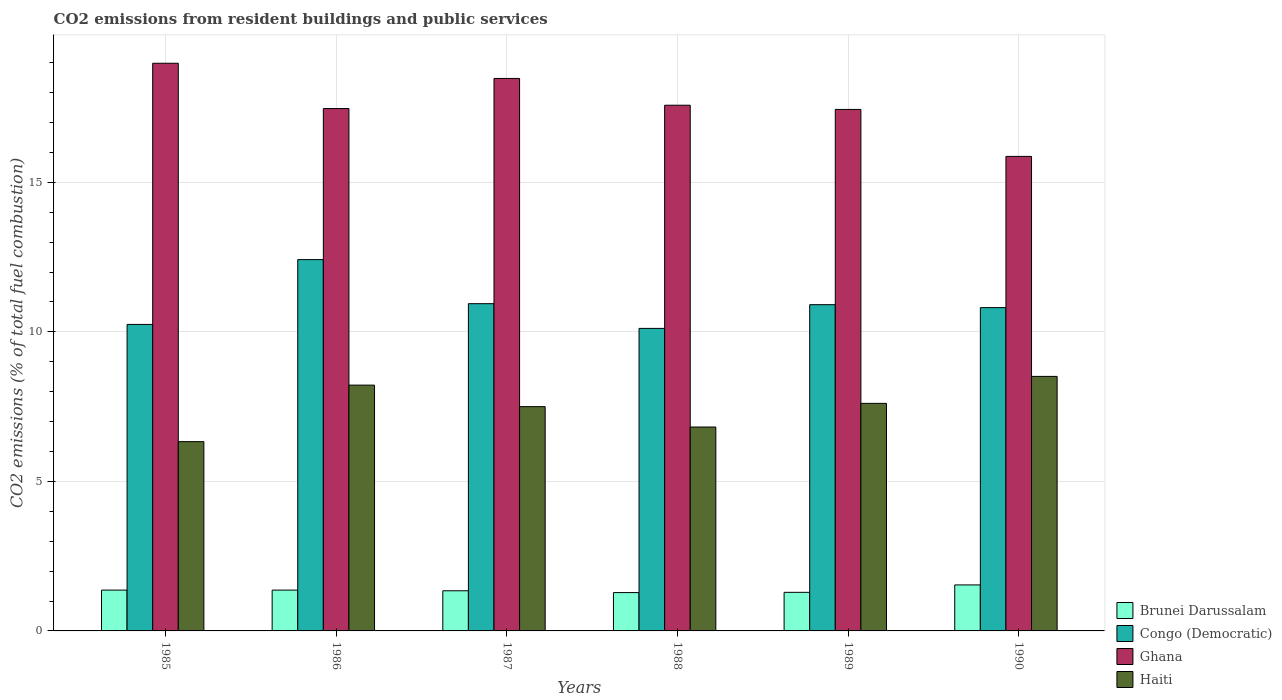Are the number of bars per tick equal to the number of legend labels?
Give a very brief answer. Yes. How many bars are there on the 2nd tick from the left?
Offer a very short reply. 4. What is the label of the 2nd group of bars from the left?
Make the answer very short. 1986. Across all years, what is the maximum total CO2 emitted in Brunei Darussalam?
Give a very brief answer. 1.54. Across all years, what is the minimum total CO2 emitted in Brunei Darussalam?
Your answer should be very brief. 1.28. In which year was the total CO2 emitted in Ghana minimum?
Provide a succinct answer. 1990. What is the total total CO2 emitted in Haiti in the graph?
Give a very brief answer. 44.99. What is the difference between the total CO2 emitted in Ghana in 1985 and that in 1990?
Provide a succinct answer. 3.11. What is the difference between the total CO2 emitted in Brunei Darussalam in 1988 and the total CO2 emitted in Haiti in 1989?
Offer a terse response. -6.33. What is the average total CO2 emitted in Ghana per year?
Offer a terse response. 17.63. In the year 1985, what is the difference between the total CO2 emitted in Congo (Democratic) and total CO2 emitted in Brunei Darussalam?
Ensure brevity in your answer.  8.88. What is the ratio of the total CO2 emitted in Haiti in 1986 to that in 1989?
Offer a very short reply. 1.08. Is the total CO2 emitted in Haiti in 1988 less than that in 1990?
Provide a short and direct response. Yes. Is the difference between the total CO2 emitted in Congo (Democratic) in 1988 and 1989 greater than the difference between the total CO2 emitted in Brunei Darussalam in 1988 and 1989?
Offer a terse response. No. What is the difference between the highest and the second highest total CO2 emitted in Brunei Darussalam?
Give a very brief answer. 0.17. What is the difference between the highest and the lowest total CO2 emitted in Congo (Democratic)?
Offer a terse response. 2.3. Is the sum of the total CO2 emitted in Congo (Democratic) in 1985 and 1989 greater than the maximum total CO2 emitted in Brunei Darussalam across all years?
Provide a short and direct response. Yes. What does the 4th bar from the left in 1989 represents?
Make the answer very short. Haiti. What does the 3rd bar from the right in 1985 represents?
Make the answer very short. Congo (Democratic). Is it the case that in every year, the sum of the total CO2 emitted in Congo (Democratic) and total CO2 emitted in Brunei Darussalam is greater than the total CO2 emitted in Ghana?
Give a very brief answer. No. Are all the bars in the graph horizontal?
Your answer should be compact. No. What is the difference between two consecutive major ticks on the Y-axis?
Your response must be concise. 5. How are the legend labels stacked?
Give a very brief answer. Vertical. What is the title of the graph?
Your answer should be very brief. CO2 emissions from resident buildings and public services. Does "Congo (Republic)" appear as one of the legend labels in the graph?
Keep it short and to the point. No. What is the label or title of the Y-axis?
Make the answer very short. CO2 emissions (% of total fuel combustion). What is the CO2 emissions (% of total fuel combustion) of Brunei Darussalam in 1985?
Your response must be concise. 1.37. What is the CO2 emissions (% of total fuel combustion) in Congo (Democratic) in 1985?
Provide a succinct answer. 10.25. What is the CO2 emissions (% of total fuel combustion) of Ghana in 1985?
Give a very brief answer. 18.98. What is the CO2 emissions (% of total fuel combustion) of Haiti in 1985?
Provide a succinct answer. 6.33. What is the CO2 emissions (% of total fuel combustion) of Brunei Darussalam in 1986?
Provide a succinct answer. 1.37. What is the CO2 emissions (% of total fuel combustion) of Congo (Democratic) in 1986?
Offer a terse response. 12.42. What is the CO2 emissions (% of total fuel combustion) in Ghana in 1986?
Provide a succinct answer. 17.47. What is the CO2 emissions (% of total fuel combustion) in Haiti in 1986?
Your answer should be compact. 8.22. What is the CO2 emissions (% of total fuel combustion) in Brunei Darussalam in 1987?
Make the answer very short. 1.34. What is the CO2 emissions (% of total fuel combustion) in Congo (Democratic) in 1987?
Keep it short and to the point. 10.94. What is the CO2 emissions (% of total fuel combustion) in Ghana in 1987?
Ensure brevity in your answer.  18.47. What is the CO2 emissions (% of total fuel combustion) in Haiti in 1987?
Ensure brevity in your answer.  7.5. What is the CO2 emissions (% of total fuel combustion) in Brunei Darussalam in 1988?
Offer a terse response. 1.28. What is the CO2 emissions (% of total fuel combustion) in Congo (Democratic) in 1988?
Provide a succinct answer. 10.12. What is the CO2 emissions (% of total fuel combustion) in Ghana in 1988?
Provide a short and direct response. 17.58. What is the CO2 emissions (% of total fuel combustion) of Haiti in 1988?
Offer a terse response. 6.82. What is the CO2 emissions (% of total fuel combustion) in Brunei Darussalam in 1989?
Provide a succinct answer. 1.29. What is the CO2 emissions (% of total fuel combustion) of Congo (Democratic) in 1989?
Keep it short and to the point. 10.91. What is the CO2 emissions (% of total fuel combustion) of Ghana in 1989?
Ensure brevity in your answer.  17.44. What is the CO2 emissions (% of total fuel combustion) in Haiti in 1989?
Your response must be concise. 7.61. What is the CO2 emissions (% of total fuel combustion) of Brunei Darussalam in 1990?
Your answer should be compact. 1.54. What is the CO2 emissions (% of total fuel combustion) in Congo (Democratic) in 1990?
Offer a very short reply. 10.81. What is the CO2 emissions (% of total fuel combustion) in Ghana in 1990?
Provide a succinct answer. 15.87. What is the CO2 emissions (% of total fuel combustion) of Haiti in 1990?
Make the answer very short. 8.51. Across all years, what is the maximum CO2 emissions (% of total fuel combustion) of Brunei Darussalam?
Offer a terse response. 1.54. Across all years, what is the maximum CO2 emissions (% of total fuel combustion) of Congo (Democratic)?
Offer a terse response. 12.42. Across all years, what is the maximum CO2 emissions (% of total fuel combustion) of Ghana?
Your response must be concise. 18.98. Across all years, what is the maximum CO2 emissions (% of total fuel combustion) of Haiti?
Offer a very short reply. 8.51. Across all years, what is the minimum CO2 emissions (% of total fuel combustion) of Brunei Darussalam?
Ensure brevity in your answer.  1.28. Across all years, what is the minimum CO2 emissions (% of total fuel combustion) in Congo (Democratic)?
Keep it short and to the point. 10.12. Across all years, what is the minimum CO2 emissions (% of total fuel combustion) in Ghana?
Offer a very short reply. 15.87. Across all years, what is the minimum CO2 emissions (% of total fuel combustion) in Haiti?
Your response must be concise. 6.33. What is the total CO2 emissions (% of total fuel combustion) of Brunei Darussalam in the graph?
Provide a succinct answer. 8.18. What is the total CO2 emissions (% of total fuel combustion) in Congo (Democratic) in the graph?
Provide a short and direct response. 65.44. What is the total CO2 emissions (% of total fuel combustion) of Ghana in the graph?
Offer a very short reply. 105.81. What is the total CO2 emissions (% of total fuel combustion) of Haiti in the graph?
Your response must be concise. 44.99. What is the difference between the CO2 emissions (% of total fuel combustion) of Brunei Darussalam in 1985 and that in 1986?
Provide a succinct answer. 0. What is the difference between the CO2 emissions (% of total fuel combustion) in Congo (Democratic) in 1985 and that in 1986?
Offer a very short reply. -2.17. What is the difference between the CO2 emissions (% of total fuel combustion) of Ghana in 1985 and that in 1986?
Ensure brevity in your answer.  1.51. What is the difference between the CO2 emissions (% of total fuel combustion) of Haiti in 1985 and that in 1986?
Your answer should be compact. -1.89. What is the difference between the CO2 emissions (% of total fuel combustion) in Brunei Darussalam in 1985 and that in 1987?
Your answer should be very brief. 0.02. What is the difference between the CO2 emissions (% of total fuel combustion) in Congo (Democratic) in 1985 and that in 1987?
Your answer should be compact. -0.69. What is the difference between the CO2 emissions (% of total fuel combustion) in Ghana in 1985 and that in 1987?
Keep it short and to the point. 0.51. What is the difference between the CO2 emissions (% of total fuel combustion) in Haiti in 1985 and that in 1987?
Offer a terse response. -1.17. What is the difference between the CO2 emissions (% of total fuel combustion) of Brunei Darussalam in 1985 and that in 1988?
Your response must be concise. 0.08. What is the difference between the CO2 emissions (% of total fuel combustion) in Congo (Democratic) in 1985 and that in 1988?
Your answer should be compact. 0.13. What is the difference between the CO2 emissions (% of total fuel combustion) of Ghana in 1985 and that in 1988?
Ensure brevity in your answer.  1.4. What is the difference between the CO2 emissions (% of total fuel combustion) in Haiti in 1985 and that in 1988?
Provide a succinct answer. -0.49. What is the difference between the CO2 emissions (% of total fuel combustion) in Brunei Darussalam in 1985 and that in 1989?
Your answer should be compact. 0.07. What is the difference between the CO2 emissions (% of total fuel combustion) of Congo (Democratic) in 1985 and that in 1989?
Your answer should be very brief. -0.66. What is the difference between the CO2 emissions (% of total fuel combustion) in Ghana in 1985 and that in 1989?
Your answer should be very brief. 1.54. What is the difference between the CO2 emissions (% of total fuel combustion) of Haiti in 1985 and that in 1989?
Provide a short and direct response. -1.28. What is the difference between the CO2 emissions (% of total fuel combustion) of Brunei Darussalam in 1985 and that in 1990?
Offer a terse response. -0.17. What is the difference between the CO2 emissions (% of total fuel combustion) of Congo (Democratic) in 1985 and that in 1990?
Offer a terse response. -0.56. What is the difference between the CO2 emissions (% of total fuel combustion) of Ghana in 1985 and that in 1990?
Provide a short and direct response. 3.11. What is the difference between the CO2 emissions (% of total fuel combustion) in Haiti in 1985 and that in 1990?
Provide a succinct answer. -2.18. What is the difference between the CO2 emissions (% of total fuel combustion) of Brunei Darussalam in 1986 and that in 1987?
Provide a succinct answer. 0.02. What is the difference between the CO2 emissions (% of total fuel combustion) in Congo (Democratic) in 1986 and that in 1987?
Provide a succinct answer. 1.47. What is the difference between the CO2 emissions (% of total fuel combustion) in Ghana in 1986 and that in 1987?
Provide a short and direct response. -1.01. What is the difference between the CO2 emissions (% of total fuel combustion) in Haiti in 1986 and that in 1987?
Give a very brief answer. 0.72. What is the difference between the CO2 emissions (% of total fuel combustion) in Brunei Darussalam in 1986 and that in 1988?
Give a very brief answer. 0.08. What is the difference between the CO2 emissions (% of total fuel combustion) of Congo (Democratic) in 1986 and that in 1988?
Offer a very short reply. 2.3. What is the difference between the CO2 emissions (% of total fuel combustion) in Ghana in 1986 and that in 1988?
Offer a terse response. -0.11. What is the difference between the CO2 emissions (% of total fuel combustion) of Haiti in 1986 and that in 1988?
Your answer should be very brief. 1.4. What is the difference between the CO2 emissions (% of total fuel combustion) of Brunei Darussalam in 1986 and that in 1989?
Offer a terse response. 0.07. What is the difference between the CO2 emissions (% of total fuel combustion) of Congo (Democratic) in 1986 and that in 1989?
Offer a terse response. 1.51. What is the difference between the CO2 emissions (% of total fuel combustion) in Ghana in 1986 and that in 1989?
Your response must be concise. 0.03. What is the difference between the CO2 emissions (% of total fuel combustion) of Haiti in 1986 and that in 1989?
Keep it short and to the point. 0.61. What is the difference between the CO2 emissions (% of total fuel combustion) of Brunei Darussalam in 1986 and that in 1990?
Your answer should be compact. -0.17. What is the difference between the CO2 emissions (% of total fuel combustion) of Congo (Democratic) in 1986 and that in 1990?
Provide a short and direct response. 1.61. What is the difference between the CO2 emissions (% of total fuel combustion) in Ghana in 1986 and that in 1990?
Make the answer very short. 1.6. What is the difference between the CO2 emissions (% of total fuel combustion) of Haiti in 1986 and that in 1990?
Provide a short and direct response. -0.29. What is the difference between the CO2 emissions (% of total fuel combustion) in Brunei Darussalam in 1987 and that in 1988?
Ensure brevity in your answer.  0.06. What is the difference between the CO2 emissions (% of total fuel combustion) of Congo (Democratic) in 1987 and that in 1988?
Ensure brevity in your answer.  0.83. What is the difference between the CO2 emissions (% of total fuel combustion) in Ghana in 1987 and that in 1988?
Provide a short and direct response. 0.9. What is the difference between the CO2 emissions (% of total fuel combustion) in Haiti in 1987 and that in 1988?
Give a very brief answer. 0.68. What is the difference between the CO2 emissions (% of total fuel combustion) in Brunei Darussalam in 1987 and that in 1989?
Ensure brevity in your answer.  0.05. What is the difference between the CO2 emissions (% of total fuel combustion) in Congo (Democratic) in 1987 and that in 1989?
Your answer should be very brief. 0.03. What is the difference between the CO2 emissions (% of total fuel combustion) of Ghana in 1987 and that in 1989?
Your response must be concise. 1.04. What is the difference between the CO2 emissions (% of total fuel combustion) of Haiti in 1987 and that in 1989?
Your answer should be compact. -0.11. What is the difference between the CO2 emissions (% of total fuel combustion) in Brunei Darussalam in 1987 and that in 1990?
Offer a very short reply. -0.2. What is the difference between the CO2 emissions (% of total fuel combustion) in Congo (Democratic) in 1987 and that in 1990?
Provide a short and direct response. 0.13. What is the difference between the CO2 emissions (% of total fuel combustion) in Ghana in 1987 and that in 1990?
Your answer should be very brief. 2.61. What is the difference between the CO2 emissions (% of total fuel combustion) in Haiti in 1987 and that in 1990?
Your answer should be very brief. -1.01. What is the difference between the CO2 emissions (% of total fuel combustion) in Brunei Darussalam in 1988 and that in 1989?
Make the answer very short. -0.01. What is the difference between the CO2 emissions (% of total fuel combustion) in Congo (Democratic) in 1988 and that in 1989?
Offer a very short reply. -0.79. What is the difference between the CO2 emissions (% of total fuel combustion) in Ghana in 1988 and that in 1989?
Your answer should be compact. 0.14. What is the difference between the CO2 emissions (% of total fuel combustion) in Haiti in 1988 and that in 1989?
Your answer should be compact. -0.79. What is the difference between the CO2 emissions (% of total fuel combustion) in Brunei Darussalam in 1988 and that in 1990?
Provide a succinct answer. -0.26. What is the difference between the CO2 emissions (% of total fuel combustion) of Congo (Democratic) in 1988 and that in 1990?
Your answer should be very brief. -0.7. What is the difference between the CO2 emissions (% of total fuel combustion) in Ghana in 1988 and that in 1990?
Your answer should be compact. 1.71. What is the difference between the CO2 emissions (% of total fuel combustion) of Haiti in 1988 and that in 1990?
Offer a very short reply. -1.69. What is the difference between the CO2 emissions (% of total fuel combustion) of Brunei Darussalam in 1989 and that in 1990?
Make the answer very short. -0.25. What is the difference between the CO2 emissions (% of total fuel combustion) in Congo (Democratic) in 1989 and that in 1990?
Offer a terse response. 0.1. What is the difference between the CO2 emissions (% of total fuel combustion) in Ghana in 1989 and that in 1990?
Provide a short and direct response. 1.57. What is the difference between the CO2 emissions (% of total fuel combustion) of Haiti in 1989 and that in 1990?
Your answer should be very brief. -0.9. What is the difference between the CO2 emissions (% of total fuel combustion) in Brunei Darussalam in 1985 and the CO2 emissions (% of total fuel combustion) in Congo (Democratic) in 1986?
Make the answer very short. -11.05. What is the difference between the CO2 emissions (% of total fuel combustion) in Brunei Darussalam in 1985 and the CO2 emissions (% of total fuel combustion) in Ghana in 1986?
Your answer should be compact. -16.1. What is the difference between the CO2 emissions (% of total fuel combustion) in Brunei Darussalam in 1985 and the CO2 emissions (% of total fuel combustion) in Haiti in 1986?
Offer a very short reply. -6.85. What is the difference between the CO2 emissions (% of total fuel combustion) in Congo (Democratic) in 1985 and the CO2 emissions (% of total fuel combustion) in Ghana in 1986?
Give a very brief answer. -7.22. What is the difference between the CO2 emissions (% of total fuel combustion) in Congo (Democratic) in 1985 and the CO2 emissions (% of total fuel combustion) in Haiti in 1986?
Keep it short and to the point. 2.03. What is the difference between the CO2 emissions (% of total fuel combustion) of Ghana in 1985 and the CO2 emissions (% of total fuel combustion) of Haiti in 1986?
Ensure brevity in your answer.  10.76. What is the difference between the CO2 emissions (% of total fuel combustion) in Brunei Darussalam in 1985 and the CO2 emissions (% of total fuel combustion) in Congo (Democratic) in 1987?
Your answer should be very brief. -9.58. What is the difference between the CO2 emissions (% of total fuel combustion) in Brunei Darussalam in 1985 and the CO2 emissions (% of total fuel combustion) in Ghana in 1987?
Provide a succinct answer. -17.11. What is the difference between the CO2 emissions (% of total fuel combustion) of Brunei Darussalam in 1985 and the CO2 emissions (% of total fuel combustion) of Haiti in 1987?
Make the answer very short. -6.13. What is the difference between the CO2 emissions (% of total fuel combustion) in Congo (Democratic) in 1985 and the CO2 emissions (% of total fuel combustion) in Ghana in 1987?
Provide a short and direct response. -8.23. What is the difference between the CO2 emissions (% of total fuel combustion) of Congo (Democratic) in 1985 and the CO2 emissions (% of total fuel combustion) of Haiti in 1987?
Provide a short and direct response. 2.75. What is the difference between the CO2 emissions (% of total fuel combustion) of Ghana in 1985 and the CO2 emissions (% of total fuel combustion) of Haiti in 1987?
Provide a short and direct response. 11.48. What is the difference between the CO2 emissions (% of total fuel combustion) in Brunei Darussalam in 1985 and the CO2 emissions (% of total fuel combustion) in Congo (Democratic) in 1988?
Offer a very short reply. -8.75. What is the difference between the CO2 emissions (% of total fuel combustion) of Brunei Darussalam in 1985 and the CO2 emissions (% of total fuel combustion) of Ghana in 1988?
Offer a very short reply. -16.21. What is the difference between the CO2 emissions (% of total fuel combustion) of Brunei Darussalam in 1985 and the CO2 emissions (% of total fuel combustion) of Haiti in 1988?
Offer a terse response. -5.45. What is the difference between the CO2 emissions (% of total fuel combustion) in Congo (Democratic) in 1985 and the CO2 emissions (% of total fuel combustion) in Ghana in 1988?
Give a very brief answer. -7.33. What is the difference between the CO2 emissions (% of total fuel combustion) of Congo (Democratic) in 1985 and the CO2 emissions (% of total fuel combustion) of Haiti in 1988?
Provide a short and direct response. 3.43. What is the difference between the CO2 emissions (% of total fuel combustion) in Ghana in 1985 and the CO2 emissions (% of total fuel combustion) in Haiti in 1988?
Make the answer very short. 12.16. What is the difference between the CO2 emissions (% of total fuel combustion) in Brunei Darussalam in 1985 and the CO2 emissions (% of total fuel combustion) in Congo (Democratic) in 1989?
Keep it short and to the point. -9.54. What is the difference between the CO2 emissions (% of total fuel combustion) in Brunei Darussalam in 1985 and the CO2 emissions (% of total fuel combustion) in Ghana in 1989?
Offer a terse response. -16.07. What is the difference between the CO2 emissions (% of total fuel combustion) in Brunei Darussalam in 1985 and the CO2 emissions (% of total fuel combustion) in Haiti in 1989?
Provide a succinct answer. -6.24. What is the difference between the CO2 emissions (% of total fuel combustion) in Congo (Democratic) in 1985 and the CO2 emissions (% of total fuel combustion) in Ghana in 1989?
Ensure brevity in your answer.  -7.19. What is the difference between the CO2 emissions (% of total fuel combustion) of Congo (Democratic) in 1985 and the CO2 emissions (% of total fuel combustion) of Haiti in 1989?
Ensure brevity in your answer.  2.64. What is the difference between the CO2 emissions (% of total fuel combustion) in Ghana in 1985 and the CO2 emissions (% of total fuel combustion) in Haiti in 1989?
Provide a short and direct response. 11.37. What is the difference between the CO2 emissions (% of total fuel combustion) in Brunei Darussalam in 1985 and the CO2 emissions (% of total fuel combustion) in Congo (Democratic) in 1990?
Offer a very short reply. -9.45. What is the difference between the CO2 emissions (% of total fuel combustion) of Brunei Darussalam in 1985 and the CO2 emissions (% of total fuel combustion) of Ghana in 1990?
Ensure brevity in your answer.  -14.5. What is the difference between the CO2 emissions (% of total fuel combustion) in Brunei Darussalam in 1985 and the CO2 emissions (% of total fuel combustion) in Haiti in 1990?
Provide a short and direct response. -7.15. What is the difference between the CO2 emissions (% of total fuel combustion) of Congo (Democratic) in 1985 and the CO2 emissions (% of total fuel combustion) of Ghana in 1990?
Make the answer very short. -5.62. What is the difference between the CO2 emissions (% of total fuel combustion) of Congo (Democratic) in 1985 and the CO2 emissions (% of total fuel combustion) of Haiti in 1990?
Make the answer very short. 1.74. What is the difference between the CO2 emissions (% of total fuel combustion) of Ghana in 1985 and the CO2 emissions (% of total fuel combustion) of Haiti in 1990?
Make the answer very short. 10.47. What is the difference between the CO2 emissions (% of total fuel combustion) of Brunei Darussalam in 1986 and the CO2 emissions (% of total fuel combustion) of Congo (Democratic) in 1987?
Your answer should be compact. -9.58. What is the difference between the CO2 emissions (% of total fuel combustion) of Brunei Darussalam in 1986 and the CO2 emissions (% of total fuel combustion) of Ghana in 1987?
Offer a terse response. -17.11. What is the difference between the CO2 emissions (% of total fuel combustion) in Brunei Darussalam in 1986 and the CO2 emissions (% of total fuel combustion) in Haiti in 1987?
Provide a short and direct response. -6.13. What is the difference between the CO2 emissions (% of total fuel combustion) in Congo (Democratic) in 1986 and the CO2 emissions (% of total fuel combustion) in Ghana in 1987?
Make the answer very short. -6.06. What is the difference between the CO2 emissions (% of total fuel combustion) of Congo (Democratic) in 1986 and the CO2 emissions (% of total fuel combustion) of Haiti in 1987?
Your answer should be compact. 4.92. What is the difference between the CO2 emissions (% of total fuel combustion) of Ghana in 1986 and the CO2 emissions (% of total fuel combustion) of Haiti in 1987?
Offer a terse response. 9.97. What is the difference between the CO2 emissions (% of total fuel combustion) of Brunei Darussalam in 1986 and the CO2 emissions (% of total fuel combustion) of Congo (Democratic) in 1988?
Ensure brevity in your answer.  -8.75. What is the difference between the CO2 emissions (% of total fuel combustion) of Brunei Darussalam in 1986 and the CO2 emissions (% of total fuel combustion) of Ghana in 1988?
Provide a short and direct response. -16.21. What is the difference between the CO2 emissions (% of total fuel combustion) in Brunei Darussalam in 1986 and the CO2 emissions (% of total fuel combustion) in Haiti in 1988?
Your answer should be compact. -5.45. What is the difference between the CO2 emissions (% of total fuel combustion) in Congo (Democratic) in 1986 and the CO2 emissions (% of total fuel combustion) in Ghana in 1988?
Provide a succinct answer. -5.16. What is the difference between the CO2 emissions (% of total fuel combustion) in Congo (Democratic) in 1986 and the CO2 emissions (% of total fuel combustion) in Haiti in 1988?
Ensure brevity in your answer.  5.6. What is the difference between the CO2 emissions (% of total fuel combustion) in Ghana in 1986 and the CO2 emissions (% of total fuel combustion) in Haiti in 1988?
Your response must be concise. 10.65. What is the difference between the CO2 emissions (% of total fuel combustion) of Brunei Darussalam in 1986 and the CO2 emissions (% of total fuel combustion) of Congo (Democratic) in 1989?
Your answer should be very brief. -9.54. What is the difference between the CO2 emissions (% of total fuel combustion) in Brunei Darussalam in 1986 and the CO2 emissions (% of total fuel combustion) in Ghana in 1989?
Give a very brief answer. -16.07. What is the difference between the CO2 emissions (% of total fuel combustion) of Brunei Darussalam in 1986 and the CO2 emissions (% of total fuel combustion) of Haiti in 1989?
Your answer should be very brief. -6.24. What is the difference between the CO2 emissions (% of total fuel combustion) in Congo (Democratic) in 1986 and the CO2 emissions (% of total fuel combustion) in Ghana in 1989?
Offer a very short reply. -5.02. What is the difference between the CO2 emissions (% of total fuel combustion) of Congo (Democratic) in 1986 and the CO2 emissions (% of total fuel combustion) of Haiti in 1989?
Ensure brevity in your answer.  4.81. What is the difference between the CO2 emissions (% of total fuel combustion) in Ghana in 1986 and the CO2 emissions (% of total fuel combustion) in Haiti in 1989?
Your answer should be compact. 9.86. What is the difference between the CO2 emissions (% of total fuel combustion) of Brunei Darussalam in 1986 and the CO2 emissions (% of total fuel combustion) of Congo (Democratic) in 1990?
Ensure brevity in your answer.  -9.45. What is the difference between the CO2 emissions (% of total fuel combustion) of Brunei Darussalam in 1986 and the CO2 emissions (% of total fuel combustion) of Ghana in 1990?
Offer a very short reply. -14.5. What is the difference between the CO2 emissions (% of total fuel combustion) in Brunei Darussalam in 1986 and the CO2 emissions (% of total fuel combustion) in Haiti in 1990?
Make the answer very short. -7.15. What is the difference between the CO2 emissions (% of total fuel combustion) in Congo (Democratic) in 1986 and the CO2 emissions (% of total fuel combustion) in Ghana in 1990?
Provide a succinct answer. -3.45. What is the difference between the CO2 emissions (% of total fuel combustion) of Congo (Democratic) in 1986 and the CO2 emissions (% of total fuel combustion) of Haiti in 1990?
Your answer should be compact. 3.91. What is the difference between the CO2 emissions (% of total fuel combustion) of Ghana in 1986 and the CO2 emissions (% of total fuel combustion) of Haiti in 1990?
Give a very brief answer. 8.96. What is the difference between the CO2 emissions (% of total fuel combustion) of Brunei Darussalam in 1987 and the CO2 emissions (% of total fuel combustion) of Congo (Democratic) in 1988?
Ensure brevity in your answer.  -8.77. What is the difference between the CO2 emissions (% of total fuel combustion) in Brunei Darussalam in 1987 and the CO2 emissions (% of total fuel combustion) in Ghana in 1988?
Offer a very short reply. -16.24. What is the difference between the CO2 emissions (% of total fuel combustion) in Brunei Darussalam in 1987 and the CO2 emissions (% of total fuel combustion) in Haiti in 1988?
Your answer should be very brief. -5.48. What is the difference between the CO2 emissions (% of total fuel combustion) in Congo (Democratic) in 1987 and the CO2 emissions (% of total fuel combustion) in Ghana in 1988?
Give a very brief answer. -6.64. What is the difference between the CO2 emissions (% of total fuel combustion) of Congo (Democratic) in 1987 and the CO2 emissions (% of total fuel combustion) of Haiti in 1988?
Offer a terse response. 4.12. What is the difference between the CO2 emissions (% of total fuel combustion) of Ghana in 1987 and the CO2 emissions (% of total fuel combustion) of Haiti in 1988?
Your response must be concise. 11.66. What is the difference between the CO2 emissions (% of total fuel combustion) of Brunei Darussalam in 1987 and the CO2 emissions (% of total fuel combustion) of Congo (Democratic) in 1989?
Keep it short and to the point. -9.57. What is the difference between the CO2 emissions (% of total fuel combustion) of Brunei Darussalam in 1987 and the CO2 emissions (% of total fuel combustion) of Ghana in 1989?
Make the answer very short. -16.1. What is the difference between the CO2 emissions (% of total fuel combustion) in Brunei Darussalam in 1987 and the CO2 emissions (% of total fuel combustion) in Haiti in 1989?
Provide a short and direct response. -6.27. What is the difference between the CO2 emissions (% of total fuel combustion) of Congo (Democratic) in 1987 and the CO2 emissions (% of total fuel combustion) of Ghana in 1989?
Your answer should be very brief. -6.5. What is the difference between the CO2 emissions (% of total fuel combustion) of Congo (Democratic) in 1987 and the CO2 emissions (% of total fuel combustion) of Haiti in 1989?
Offer a terse response. 3.33. What is the difference between the CO2 emissions (% of total fuel combustion) of Ghana in 1987 and the CO2 emissions (% of total fuel combustion) of Haiti in 1989?
Your response must be concise. 10.87. What is the difference between the CO2 emissions (% of total fuel combustion) in Brunei Darussalam in 1987 and the CO2 emissions (% of total fuel combustion) in Congo (Democratic) in 1990?
Your answer should be very brief. -9.47. What is the difference between the CO2 emissions (% of total fuel combustion) of Brunei Darussalam in 1987 and the CO2 emissions (% of total fuel combustion) of Ghana in 1990?
Offer a very short reply. -14.52. What is the difference between the CO2 emissions (% of total fuel combustion) in Brunei Darussalam in 1987 and the CO2 emissions (% of total fuel combustion) in Haiti in 1990?
Your answer should be very brief. -7.17. What is the difference between the CO2 emissions (% of total fuel combustion) of Congo (Democratic) in 1987 and the CO2 emissions (% of total fuel combustion) of Ghana in 1990?
Offer a terse response. -4.92. What is the difference between the CO2 emissions (% of total fuel combustion) in Congo (Democratic) in 1987 and the CO2 emissions (% of total fuel combustion) in Haiti in 1990?
Offer a terse response. 2.43. What is the difference between the CO2 emissions (% of total fuel combustion) of Ghana in 1987 and the CO2 emissions (% of total fuel combustion) of Haiti in 1990?
Your response must be concise. 9.96. What is the difference between the CO2 emissions (% of total fuel combustion) of Brunei Darussalam in 1988 and the CO2 emissions (% of total fuel combustion) of Congo (Democratic) in 1989?
Offer a very short reply. -9.63. What is the difference between the CO2 emissions (% of total fuel combustion) in Brunei Darussalam in 1988 and the CO2 emissions (% of total fuel combustion) in Ghana in 1989?
Offer a very short reply. -16.16. What is the difference between the CO2 emissions (% of total fuel combustion) of Brunei Darussalam in 1988 and the CO2 emissions (% of total fuel combustion) of Haiti in 1989?
Provide a short and direct response. -6.33. What is the difference between the CO2 emissions (% of total fuel combustion) in Congo (Democratic) in 1988 and the CO2 emissions (% of total fuel combustion) in Ghana in 1989?
Your response must be concise. -7.32. What is the difference between the CO2 emissions (% of total fuel combustion) of Congo (Democratic) in 1988 and the CO2 emissions (% of total fuel combustion) of Haiti in 1989?
Provide a succinct answer. 2.51. What is the difference between the CO2 emissions (% of total fuel combustion) of Ghana in 1988 and the CO2 emissions (% of total fuel combustion) of Haiti in 1989?
Keep it short and to the point. 9.97. What is the difference between the CO2 emissions (% of total fuel combustion) of Brunei Darussalam in 1988 and the CO2 emissions (% of total fuel combustion) of Congo (Democratic) in 1990?
Provide a short and direct response. -9.53. What is the difference between the CO2 emissions (% of total fuel combustion) in Brunei Darussalam in 1988 and the CO2 emissions (% of total fuel combustion) in Ghana in 1990?
Keep it short and to the point. -14.59. What is the difference between the CO2 emissions (% of total fuel combustion) of Brunei Darussalam in 1988 and the CO2 emissions (% of total fuel combustion) of Haiti in 1990?
Offer a terse response. -7.23. What is the difference between the CO2 emissions (% of total fuel combustion) of Congo (Democratic) in 1988 and the CO2 emissions (% of total fuel combustion) of Ghana in 1990?
Your answer should be compact. -5.75. What is the difference between the CO2 emissions (% of total fuel combustion) in Congo (Democratic) in 1988 and the CO2 emissions (% of total fuel combustion) in Haiti in 1990?
Ensure brevity in your answer.  1.6. What is the difference between the CO2 emissions (% of total fuel combustion) in Ghana in 1988 and the CO2 emissions (% of total fuel combustion) in Haiti in 1990?
Give a very brief answer. 9.07. What is the difference between the CO2 emissions (% of total fuel combustion) in Brunei Darussalam in 1989 and the CO2 emissions (% of total fuel combustion) in Congo (Democratic) in 1990?
Your answer should be very brief. -9.52. What is the difference between the CO2 emissions (% of total fuel combustion) of Brunei Darussalam in 1989 and the CO2 emissions (% of total fuel combustion) of Ghana in 1990?
Offer a very short reply. -14.58. What is the difference between the CO2 emissions (% of total fuel combustion) of Brunei Darussalam in 1989 and the CO2 emissions (% of total fuel combustion) of Haiti in 1990?
Keep it short and to the point. -7.22. What is the difference between the CO2 emissions (% of total fuel combustion) in Congo (Democratic) in 1989 and the CO2 emissions (% of total fuel combustion) in Ghana in 1990?
Keep it short and to the point. -4.96. What is the difference between the CO2 emissions (% of total fuel combustion) of Congo (Democratic) in 1989 and the CO2 emissions (% of total fuel combustion) of Haiti in 1990?
Ensure brevity in your answer.  2.4. What is the difference between the CO2 emissions (% of total fuel combustion) of Ghana in 1989 and the CO2 emissions (% of total fuel combustion) of Haiti in 1990?
Keep it short and to the point. 8.93. What is the average CO2 emissions (% of total fuel combustion) in Brunei Darussalam per year?
Provide a succinct answer. 1.36. What is the average CO2 emissions (% of total fuel combustion) of Congo (Democratic) per year?
Give a very brief answer. 10.91. What is the average CO2 emissions (% of total fuel combustion) of Ghana per year?
Your answer should be compact. 17.63. What is the average CO2 emissions (% of total fuel combustion) in Haiti per year?
Offer a very short reply. 7.5. In the year 1985, what is the difference between the CO2 emissions (% of total fuel combustion) in Brunei Darussalam and CO2 emissions (% of total fuel combustion) in Congo (Democratic)?
Offer a terse response. -8.88. In the year 1985, what is the difference between the CO2 emissions (% of total fuel combustion) of Brunei Darussalam and CO2 emissions (% of total fuel combustion) of Ghana?
Your response must be concise. -17.62. In the year 1985, what is the difference between the CO2 emissions (% of total fuel combustion) in Brunei Darussalam and CO2 emissions (% of total fuel combustion) in Haiti?
Offer a terse response. -4.96. In the year 1985, what is the difference between the CO2 emissions (% of total fuel combustion) in Congo (Democratic) and CO2 emissions (% of total fuel combustion) in Ghana?
Give a very brief answer. -8.73. In the year 1985, what is the difference between the CO2 emissions (% of total fuel combustion) of Congo (Democratic) and CO2 emissions (% of total fuel combustion) of Haiti?
Your answer should be very brief. 3.92. In the year 1985, what is the difference between the CO2 emissions (% of total fuel combustion) in Ghana and CO2 emissions (% of total fuel combustion) in Haiti?
Offer a very short reply. 12.65. In the year 1986, what is the difference between the CO2 emissions (% of total fuel combustion) of Brunei Darussalam and CO2 emissions (% of total fuel combustion) of Congo (Democratic)?
Your answer should be very brief. -11.05. In the year 1986, what is the difference between the CO2 emissions (% of total fuel combustion) in Brunei Darussalam and CO2 emissions (% of total fuel combustion) in Ghana?
Provide a short and direct response. -16.1. In the year 1986, what is the difference between the CO2 emissions (% of total fuel combustion) in Brunei Darussalam and CO2 emissions (% of total fuel combustion) in Haiti?
Offer a terse response. -6.85. In the year 1986, what is the difference between the CO2 emissions (% of total fuel combustion) in Congo (Democratic) and CO2 emissions (% of total fuel combustion) in Ghana?
Your response must be concise. -5.05. In the year 1986, what is the difference between the CO2 emissions (% of total fuel combustion) in Congo (Democratic) and CO2 emissions (% of total fuel combustion) in Haiti?
Your answer should be compact. 4.2. In the year 1986, what is the difference between the CO2 emissions (% of total fuel combustion) of Ghana and CO2 emissions (% of total fuel combustion) of Haiti?
Keep it short and to the point. 9.25. In the year 1987, what is the difference between the CO2 emissions (% of total fuel combustion) of Brunei Darussalam and CO2 emissions (% of total fuel combustion) of Congo (Democratic)?
Provide a succinct answer. -9.6. In the year 1987, what is the difference between the CO2 emissions (% of total fuel combustion) of Brunei Darussalam and CO2 emissions (% of total fuel combustion) of Ghana?
Keep it short and to the point. -17.13. In the year 1987, what is the difference between the CO2 emissions (% of total fuel combustion) of Brunei Darussalam and CO2 emissions (% of total fuel combustion) of Haiti?
Offer a terse response. -6.16. In the year 1987, what is the difference between the CO2 emissions (% of total fuel combustion) of Congo (Democratic) and CO2 emissions (% of total fuel combustion) of Ghana?
Ensure brevity in your answer.  -7.53. In the year 1987, what is the difference between the CO2 emissions (% of total fuel combustion) in Congo (Democratic) and CO2 emissions (% of total fuel combustion) in Haiti?
Keep it short and to the point. 3.44. In the year 1987, what is the difference between the CO2 emissions (% of total fuel combustion) of Ghana and CO2 emissions (% of total fuel combustion) of Haiti?
Give a very brief answer. 10.97. In the year 1988, what is the difference between the CO2 emissions (% of total fuel combustion) in Brunei Darussalam and CO2 emissions (% of total fuel combustion) in Congo (Democratic)?
Your answer should be compact. -8.83. In the year 1988, what is the difference between the CO2 emissions (% of total fuel combustion) in Brunei Darussalam and CO2 emissions (% of total fuel combustion) in Ghana?
Offer a very short reply. -16.3. In the year 1988, what is the difference between the CO2 emissions (% of total fuel combustion) of Brunei Darussalam and CO2 emissions (% of total fuel combustion) of Haiti?
Offer a terse response. -5.54. In the year 1988, what is the difference between the CO2 emissions (% of total fuel combustion) of Congo (Democratic) and CO2 emissions (% of total fuel combustion) of Ghana?
Your answer should be compact. -7.46. In the year 1988, what is the difference between the CO2 emissions (% of total fuel combustion) of Congo (Democratic) and CO2 emissions (% of total fuel combustion) of Haiti?
Your answer should be very brief. 3.3. In the year 1988, what is the difference between the CO2 emissions (% of total fuel combustion) of Ghana and CO2 emissions (% of total fuel combustion) of Haiti?
Your answer should be compact. 10.76. In the year 1989, what is the difference between the CO2 emissions (% of total fuel combustion) of Brunei Darussalam and CO2 emissions (% of total fuel combustion) of Congo (Democratic)?
Your answer should be compact. -9.62. In the year 1989, what is the difference between the CO2 emissions (% of total fuel combustion) in Brunei Darussalam and CO2 emissions (% of total fuel combustion) in Ghana?
Ensure brevity in your answer.  -16.15. In the year 1989, what is the difference between the CO2 emissions (% of total fuel combustion) of Brunei Darussalam and CO2 emissions (% of total fuel combustion) of Haiti?
Your answer should be compact. -6.32. In the year 1989, what is the difference between the CO2 emissions (% of total fuel combustion) of Congo (Democratic) and CO2 emissions (% of total fuel combustion) of Ghana?
Ensure brevity in your answer.  -6.53. In the year 1989, what is the difference between the CO2 emissions (% of total fuel combustion) in Congo (Democratic) and CO2 emissions (% of total fuel combustion) in Haiti?
Keep it short and to the point. 3.3. In the year 1989, what is the difference between the CO2 emissions (% of total fuel combustion) of Ghana and CO2 emissions (% of total fuel combustion) of Haiti?
Ensure brevity in your answer.  9.83. In the year 1990, what is the difference between the CO2 emissions (% of total fuel combustion) of Brunei Darussalam and CO2 emissions (% of total fuel combustion) of Congo (Democratic)?
Give a very brief answer. -9.27. In the year 1990, what is the difference between the CO2 emissions (% of total fuel combustion) in Brunei Darussalam and CO2 emissions (% of total fuel combustion) in Ghana?
Your response must be concise. -14.33. In the year 1990, what is the difference between the CO2 emissions (% of total fuel combustion) in Brunei Darussalam and CO2 emissions (% of total fuel combustion) in Haiti?
Ensure brevity in your answer.  -6.97. In the year 1990, what is the difference between the CO2 emissions (% of total fuel combustion) in Congo (Democratic) and CO2 emissions (% of total fuel combustion) in Ghana?
Provide a short and direct response. -5.06. In the year 1990, what is the difference between the CO2 emissions (% of total fuel combustion) of Congo (Democratic) and CO2 emissions (% of total fuel combustion) of Haiti?
Offer a very short reply. 2.3. In the year 1990, what is the difference between the CO2 emissions (% of total fuel combustion) of Ghana and CO2 emissions (% of total fuel combustion) of Haiti?
Your answer should be compact. 7.36. What is the ratio of the CO2 emissions (% of total fuel combustion) of Congo (Democratic) in 1985 to that in 1986?
Keep it short and to the point. 0.83. What is the ratio of the CO2 emissions (% of total fuel combustion) of Ghana in 1985 to that in 1986?
Offer a terse response. 1.09. What is the ratio of the CO2 emissions (% of total fuel combustion) of Haiti in 1985 to that in 1986?
Provide a succinct answer. 0.77. What is the ratio of the CO2 emissions (% of total fuel combustion) in Brunei Darussalam in 1985 to that in 1987?
Your response must be concise. 1.02. What is the ratio of the CO2 emissions (% of total fuel combustion) of Congo (Democratic) in 1985 to that in 1987?
Offer a very short reply. 0.94. What is the ratio of the CO2 emissions (% of total fuel combustion) in Ghana in 1985 to that in 1987?
Give a very brief answer. 1.03. What is the ratio of the CO2 emissions (% of total fuel combustion) in Haiti in 1985 to that in 1987?
Ensure brevity in your answer.  0.84. What is the ratio of the CO2 emissions (% of total fuel combustion) of Brunei Darussalam in 1985 to that in 1988?
Offer a very short reply. 1.06. What is the ratio of the CO2 emissions (% of total fuel combustion) of Congo (Democratic) in 1985 to that in 1988?
Keep it short and to the point. 1.01. What is the ratio of the CO2 emissions (% of total fuel combustion) of Ghana in 1985 to that in 1988?
Offer a very short reply. 1.08. What is the ratio of the CO2 emissions (% of total fuel combustion) in Haiti in 1985 to that in 1988?
Keep it short and to the point. 0.93. What is the ratio of the CO2 emissions (% of total fuel combustion) in Brunei Darussalam in 1985 to that in 1989?
Provide a short and direct response. 1.06. What is the ratio of the CO2 emissions (% of total fuel combustion) of Congo (Democratic) in 1985 to that in 1989?
Offer a terse response. 0.94. What is the ratio of the CO2 emissions (% of total fuel combustion) of Ghana in 1985 to that in 1989?
Your response must be concise. 1.09. What is the ratio of the CO2 emissions (% of total fuel combustion) in Haiti in 1985 to that in 1989?
Provide a short and direct response. 0.83. What is the ratio of the CO2 emissions (% of total fuel combustion) in Brunei Darussalam in 1985 to that in 1990?
Ensure brevity in your answer.  0.89. What is the ratio of the CO2 emissions (% of total fuel combustion) in Congo (Democratic) in 1985 to that in 1990?
Offer a terse response. 0.95. What is the ratio of the CO2 emissions (% of total fuel combustion) in Ghana in 1985 to that in 1990?
Provide a short and direct response. 1.2. What is the ratio of the CO2 emissions (% of total fuel combustion) of Haiti in 1985 to that in 1990?
Provide a succinct answer. 0.74. What is the ratio of the CO2 emissions (% of total fuel combustion) of Brunei Darussalam in 1986 to that in 1987?
Keep it short and to the point. 1.02. What is the ratio of the CO2 emissions (% of total fuel combustion) of Congo (Democratic) in 1986 to that in 1987?
Provide a short and direct response. 1.13. What is the ratio of the CO2 emissions (% of total fuel combustion) in Ghana in 1986 to that in 1987?
Offer a very short reply. 0.95. What is the ratio of the CO2 emissions (% of total fuel combustion) of Haiti in 1986 to that in 1987?
Offer a very short reply. 1.1. What is the ratio of the CO2 emissions (% of total fuel combustion) in Brunei Darussalam in 1986 to that in 1988?
Your answer should be very brief. 1.06. What is the ratio of the CO2 emissions (% of total fuel combustion) of Congo (Democratic) in 1986 to that in 1988?
Your answer should be compact. 1.23. What is the ratio of the CO2 emissions (% of total fuel combustion) of Haiti in 1986 to that in 1988?
Keep it short and to the point. 1.21. What is the ratio of the CO2 emissions (% of total fuel combustion) of Brunei Darussalam in 1986 to that in 1989?
Make the answer very short. 1.06. What is the ratio of the CO2 emissions (% of total fuel combustion) in Congo (Democratic) in 1986 to that in 1989?
Keep it short and to the point. 1.14. What is the ratio of the CO2 emissions (% of total fuel combustion) of Haiti in 1986 to that in 1989?
Make the answer very short. 1.08. What is the ratio of the CO2 emissions (% of total fuel combustion) in Brunei Darussalam in 1986 to that in 1990?
Your answer should be very brief. 0.89. What is the ratio of the CO2 emissions (% of total fuel combustion) of Congo (Democratic) in 1986 to that in 1990?
Offer a very short reply. 1.15. What is the ratio of the CO2 emissions (% of total fuel combustion) of Ghana in 1986 to that in 1990?
Make the answer very short. 1.1. What is the ratio of the CO2 emissions (% of total fuel combustion) of Haiti in 1986 to that in 1990?
Provide a succinct answer. 0.97. What is the ratio of the CO2 emissions (% of total fuel combustion) in Brunei Darussalam in 1987 to that in 1988?
Ensure brevity in your answer.  1.05. What is the ratio of the CO2 emissions (% of total fuel combustion) in Congo (Democratic) in 1987 to that in 1988?
Keep it short and to the point. 1.08. What is the ratio of the CO2 emissions (% of total fuel combustion) in Ghana in 1987 to that in 1988?
Offer a terse response. 1.05. What is the ratio of the CO2 emissions (% of total fuel combustion) of Brunei Darussalam in 1987 to that in 1989?
Offer a very short reply. 1.04. What is the ratio of the CO2 emissions (% of total fuel combustion) of Ghana in 1987 to that in 1989?
Provide a short and direct response. 1.06. What is the ratio of the CO2 emissions (% of total fuel combustion) of Haiti in 1987 to that in 1989?
Ensure brevity in your answer.  0.99. What is the ratio of the CO2 emissions (% of total fuel combustion) in Brunei Darussalam in 1987 to that in 1990?
Give a very brief answer. 0.87. What is the ratio of the CO2 emissions (% of total fuel combustion) in Congo (Democratic) in 1987 to that in 1990?
Give a very brief answer. 1.01. What is the ratio of the CO2 emissions (% of total fuel combustion) of Ghana in 1987 to that in 1990?
Your answer should be very brief. 1.16. What is the ratio of the CO2 emissions (% of total fuel combustion) in Haiti in 1987 to that in 1990?
Offer a terse response. 0.88. What is the ratio of the CO2 emissions (% of total fuel combustion) of Congo (Democratic) in 1988 to that in 1989?
Your answer should be very brief. 0.93. What is the ratio of the CO2 emissions (% of total fuel combustion) of Ghana in 1988 to that in 1989?
Your response must be concise. 1.01. What is the ratio of the CO2 emissions (% of total fuel combustion) of Haiti in 1988 to that in 1989?
Offer a terse response. 0.9. What is the ratio of the CO2 emissions (% of total fuel combustion) of Congo (Democratic) in 1988 to that in 1990?
Provide a short and direct response. 0.94. What is the ratio of the CO2 emissions (% of total fuel combustion) in Ghana in 1988 to that in 1990?
Make the answer very short. 1.11. What is the ratio of the CO2 emissions (% of total fuel combustion) in Haiti in 1988 to that in 1990?
Provide a short and direct response. 0.8. What is the ratio of the CO2 emissions (% of total fuel combustion) of Brunei Darussalam in 1989 to that in 1990?
Offer a very short reply. 0.84. What is the ratio of the CO2 emissions (% of total fuel combustion) in Congo (Democratic) in 1989 to that in 1990?
Your response must be concise. 1.01. What is the ratio of the CO2 emissions (% of total fuel combustion) of Ghana in 1989 to that in 1990?
Your response must be concise. 1.1. What is the ratio of the CO2 emissions (% of total fuel combustion) in Haiti in 1989 to that in 1990?
Ensure brevity in your answer.  0.89. What is the difference between the highest and the second highest CO2 emissions (% of total fuel combustion) of Brunei Darussalam?
Keep it short and to the point. 0.17. What is the difference between the highest and the second highest CO2 emissions (% of total fuel combustion) in Congo (Democratic)?
Give a very brief answer. 1.47. What is the difference between the highest and the second highest CO2 emissions (% of total fuel combustion) in Ghana?
Your answer should be compact. 0.51. What is the difference between the highest and the second highest CO2 emissions (% of total fuel combustion) in Haiti?
Your answer should be very brief. 0.29. What is the difference between the highest and the lowest CO2 emissions (% of total fuel combustion) of Brunei Darussalam?
Your response must be concise. 0.26. What is the difference between the highest and the lowest CO2 emissions (% of total fuel combustion) in Congo (Democratic)?
Your response must be concise. 2.3. What is the difference between the highest and the lowest CO2 emissions (% of total fuel combustion) in Ghana?
Make the answer very short. 3.11. What is the difference between the highest and the lowest CO2 emissions (% of total fuel combustion) in Haiti?
Offer a very short reply. 2.18. 